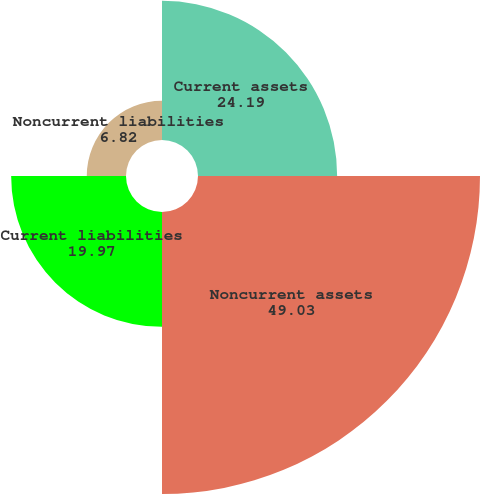Convert chart to OTSL. <chart><loc_0><loc_0><loc_500><loc_500><pie_chart><fcel>Current assets<fcel>Noncurrent assets<fcel>Current liabilities<fcel>Noncurrent liabilities<nl><fcel>24.19%<fcel>49.03%<fcel>19.97%<fcel>6.82%<nl></chart> 